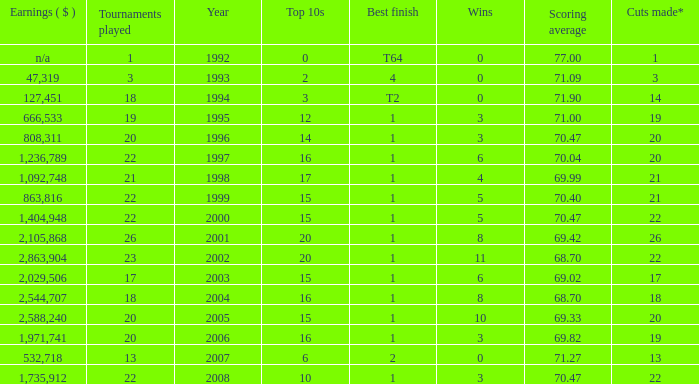Would you be able to parse every entry in this table? {'header': ['Earnings ( $ )', 'Tournaments played', 'Year', 'Top 10s', 'Best finish', 'Wins', 'Scoring average', 'Cuts made*'], 'rows': [['n/a', '1', '1992', '0', 'T64', '0', '77.00', '1'], ['47,319', '3', '1993', '2', '4', '0', '71.09', '3'], ['127,451', '18', '1994', '3', 'T2', '0', '71.90', '14'], ['666,533', '19', '1995', '12', '1', '3', '71.00', '19'], ['808,311', '20', '1996', '14', '1', '3', '70.47', '20'], ['1,236,789', '22', '1997', '16', '1', '6', '70.04', '20'], ['1,092,748', '21', '1998', '17', '1', '4', '69.99', '21'], ['863,816', '22', '1999', '15', '1', '5', '70.40', '21'], ['1,404,948', '22', '2000', '15', '1', '5', '70.47', '22'], ['2,105,868', '26', '2001', '20', '1', '8', '69.42', '26'], ['2,863,904', '23', '2002', '20', '1', '11', '68.70', '22'], ['2,029,506', '17', '2003', '15', '1', '6', '69.02', '17'], ['2,544,707', '18', '2004', '16', '1', '8', '68.70', '18'], ['2,588,240', '20', '2005', '15', '1', '10', '69.33', '20'], ['1,971,741', '20', '2006', '16', '1', '3', '69.82', '19'], ['532,718', '13', '2007', '6', '2', '0', '71.27', '13'], ['1,735,912', '22', '2008', '10', '1', '3', '70.47', '22']]} Tell me the highest wins for year less than 2000 and best finish of 4 and tournaments played less than 3 None. 